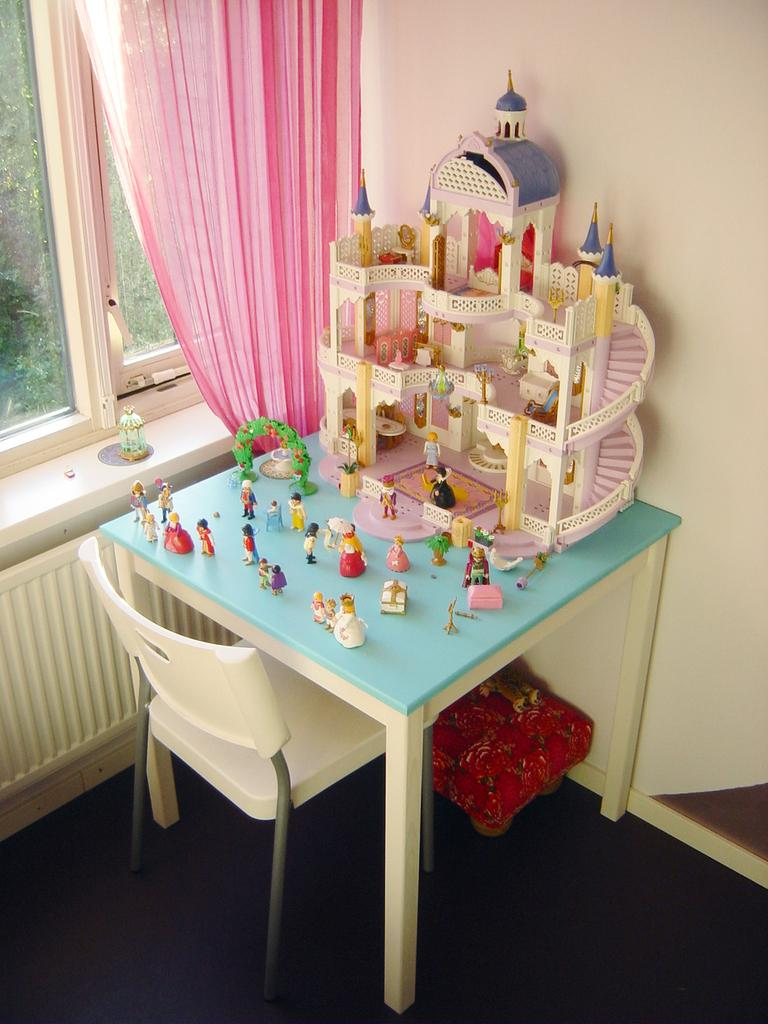What type of furniture is present in the image? There is a table and a chair in the image. What is on the table in the image? There are toys on the table in the image. What can be seen near the window in the image? There is a curtain associated with the window in the image. What is the background of the image made of? The background of the image includes a wall and a floor. What type of land can be seen through the window in the image? There is no land visible through the window in the image; it only shows a curtain. Is there a zipper on the curtain in the image? There is no zipper present on the curtain in the image. 